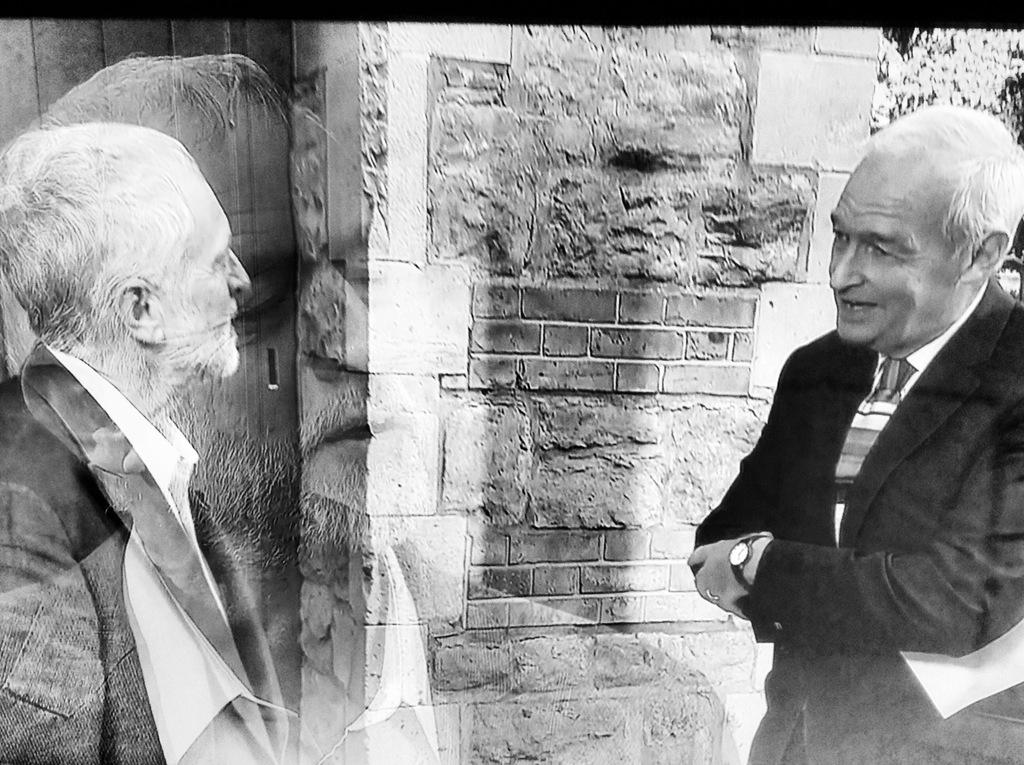What is the main subject of the image? The main subject of the image is men standing. Can you describe the background of the image? There is a wall in the background of the image. What type of slope can be seen in the image? There is no slope present in the image; it features men standing in front of a wall. What is the manager doing in the image? There is no manager present in the image, as it only features men standing. 